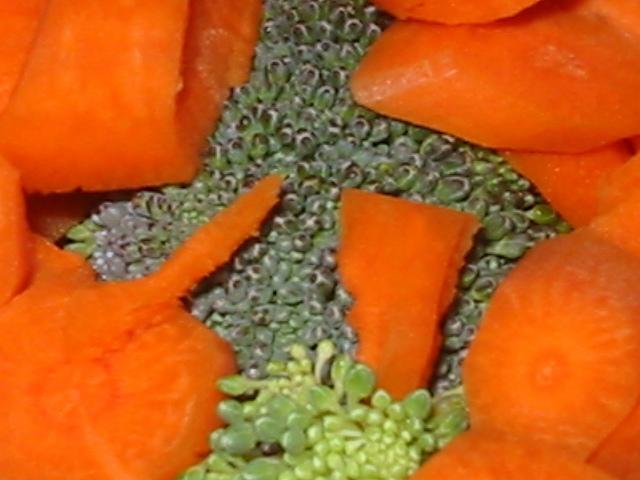Is the orange vegetable yams?
Short answer required. No. Can you eat this?
Answer briefly. Yes. What is the green vegetable?
Answer briefly. Broccoli. 